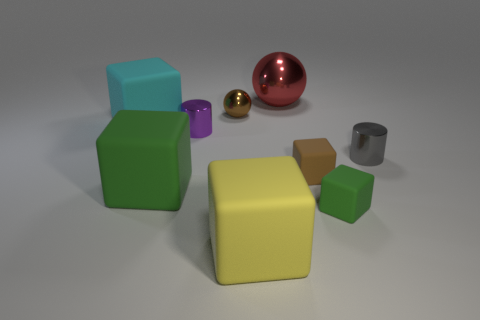Subtract all big green matte cubes. How many cubes are left? 4 Subtract all purple cylinders. How many cylinders are left? 1 Subtract 1 balls. How many balls are left? 1 Subtract all blocks. How many objects are left? 4 Add 1 gray rubber cubes. How many objects exist? 10 Add 6 tiny metallic spheres. How many tiny metallic spheres exist? 7 Subtract 0 brown cylinders. How many objects are left? 9 Subtract all green balls. Subtract all blue cylinders. How many balls are left? 2 Subtract all green balls. How many purple blocks are left? 0 Subtract all large red metal things. Subtract all small brown rubber blocks. How many objects are left? 7 